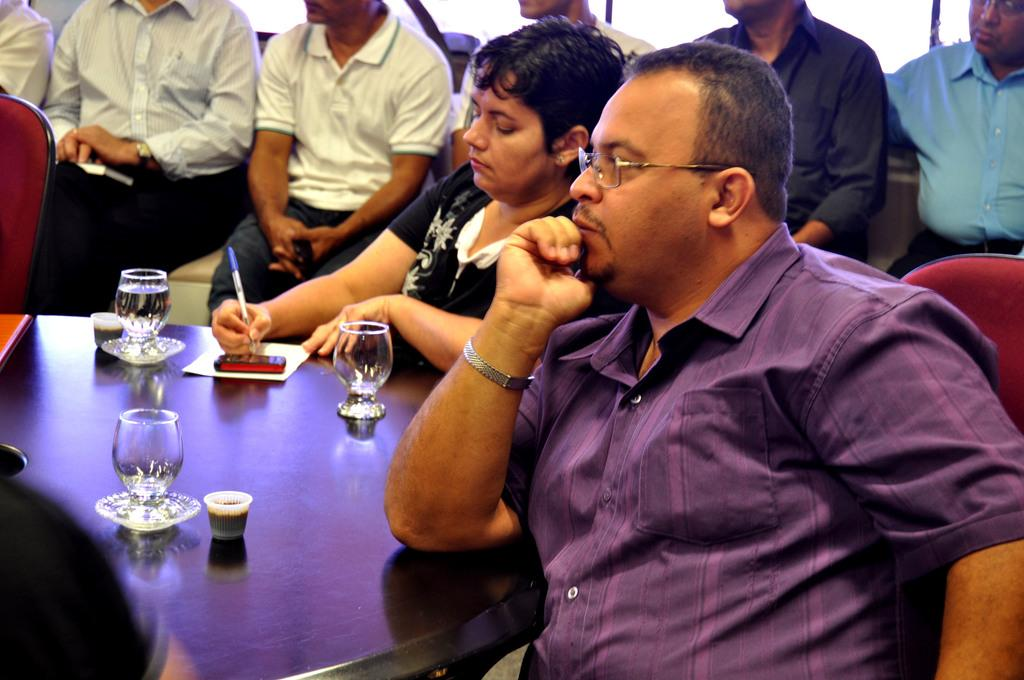What are the people in the image doing? The people in the image are sitting on chairs. What is present on the table in the image? There is a table in the image, and on it, there are glasses, a mobile phone, a paper, and a pen. What might the people be using the glasses for? The glasses on the table might be used for drinking. What is the purpose of the pen on the table? The pen on the table might be used for writing or drawing. What type of spoon can be seen in the image? There is no spoon present in the image. What time does the watch on the table show in the image? There is no watch present in the image. 